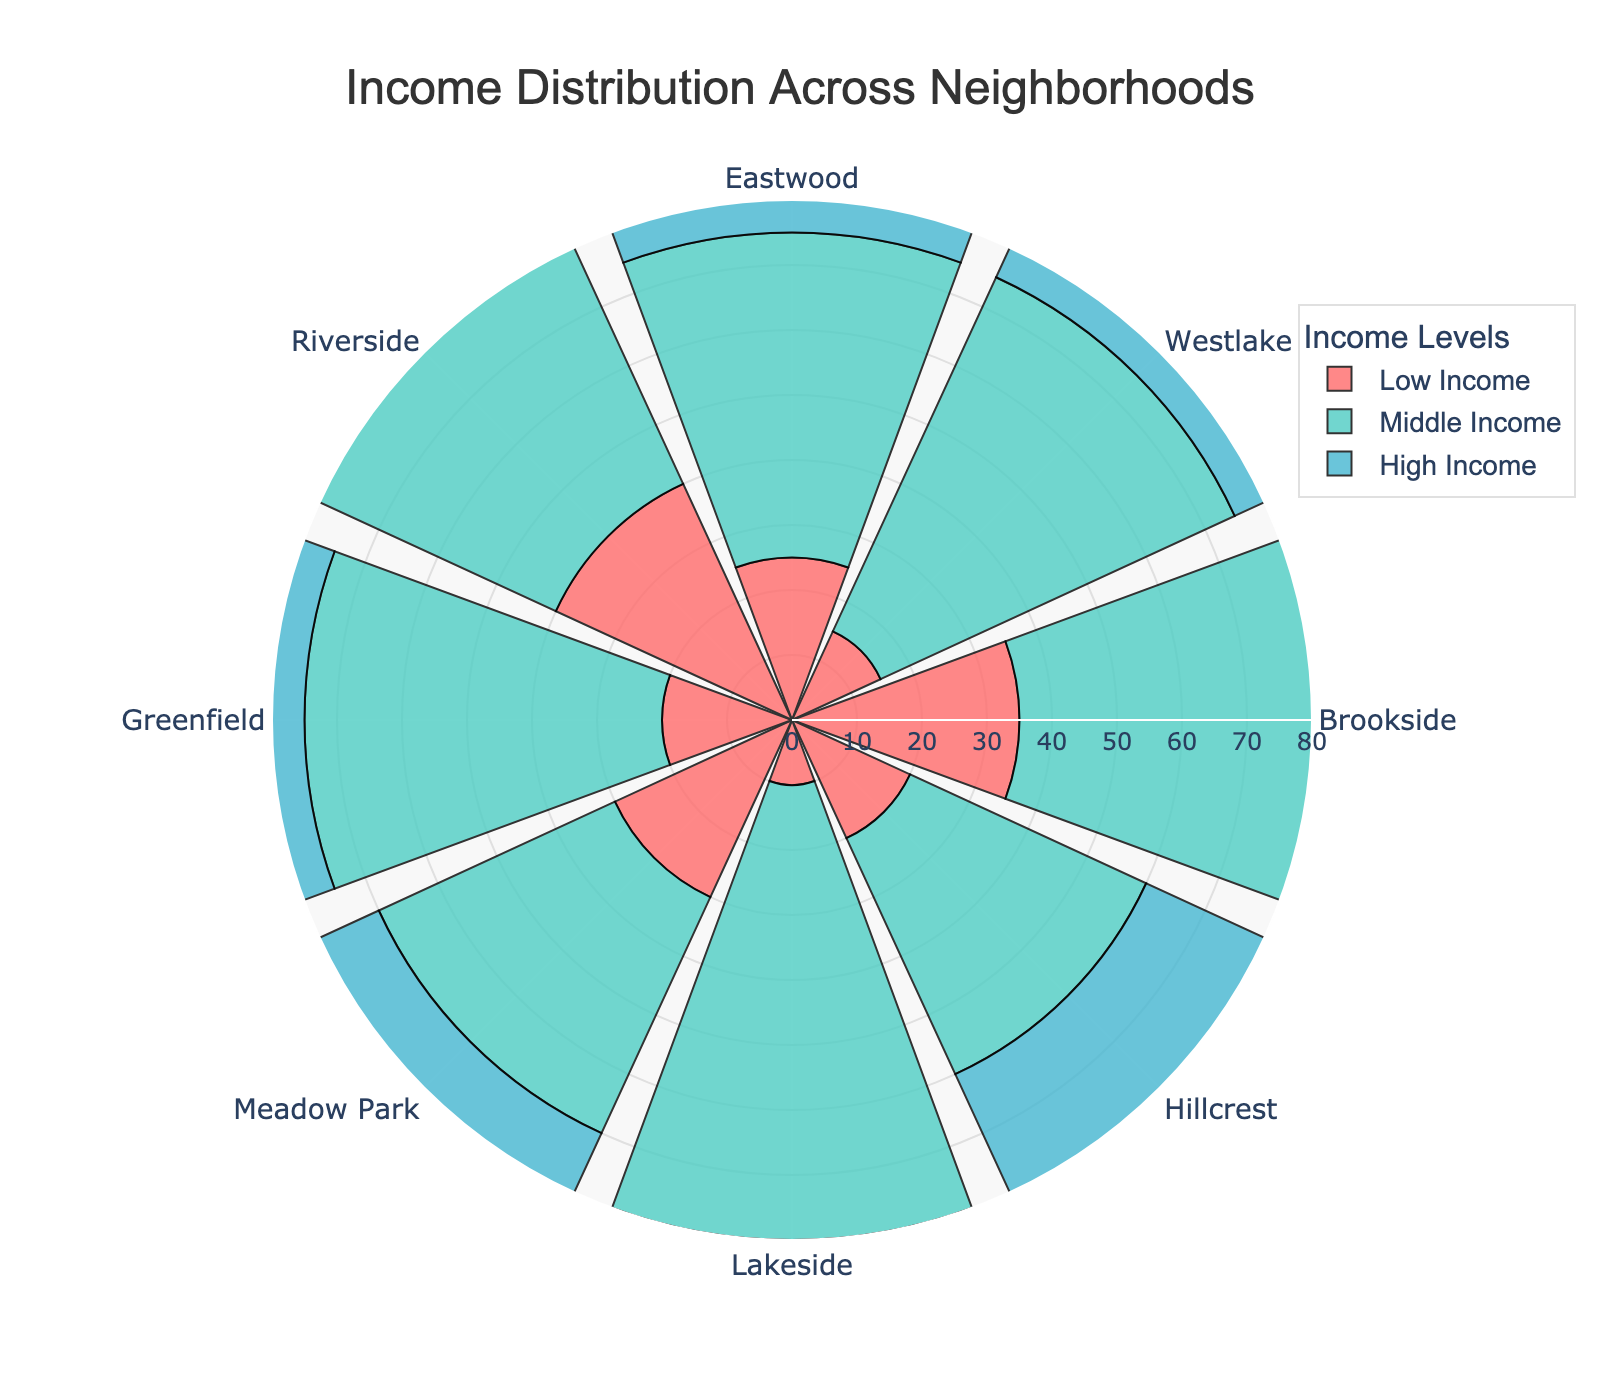Which neighborhood has the highest percentage of low-income households? By looking at the segment for Low Income in the polar area chart, the neighborhood with the largest radius (longest segment) represents the highest percentage of low-income households. Here, it's Riverside.
Answer: Riverside Which income level is the most dominant in Lakeside? Observing Lakeside on the polar area chart, the largest segment is for Middle Income, indicating it is the most dominant income level.
Answer: Middle Income How does the percentage of high-income households in Hillcrest compare to those in Brookside? Comparing the high-income segments for Hillcrest and Brookside on the chart, Hillcrest has a noticeably longer bar, indicating it has a higher percentage of high-income households compared to Brookside.
Answer: Higher What is the average percentage of middle-income households across all neighborhoods? Sum the middle-income percentages for all neighborhoods: 50 + 60 + 50 + 40 + 70 + 40 + 55 + 45 = 410. Divide by the number of neighborhoods: 410 / 8 = 51.25.
Answer: 51.25 Which neighborhood has the lowest percentage of middle-income households? By observing the Middle Income segments on the chart, the neighborhood with the shortest radius (smallest segment) represents the lowest percentage of middle-income households, which is Hillcrest.
Answer: Hillcrest Is there any neighborhood where the percentage of high-income households is the same as low-income households? By examining the segments for both Low Income and High Income across all neighborhoods, Eastwood and Meadow Park are the only neighborhoods where the segments are equal in length, indicating equal percentages.
Answer: Eastwood and Meadow Park What's the total percentage of low-income households in Eastwood and Riverside combined? Sum the low-income percentages for Eastwood and Riverside: 25 + 40 = 65.
Answer: 65 Compare the percentage of middle-income households between Eastwood and Westlake. Which is higher and by how much? Comparing the middle-income segments, Westlake has a middle-income percentage of 60, while Eastwood has 50. The difference is 60 - 50 = 10.
Answer: Westlake by 10 Which neighborhood has a more balanced distribution of income levels? Observing the chart, a balanced distribution would have segments (bars) of nearly equal length. Eastwood shows an equal distribution: 25% for Low, Middle, and High Income.
Answer: Eastwood What is the combined percentage of high-income households in Greenfield and Lakeside? Sum the high-income percentages for Greenfield and Lakeside: 25 + 20 = 45.
Answer: 45 